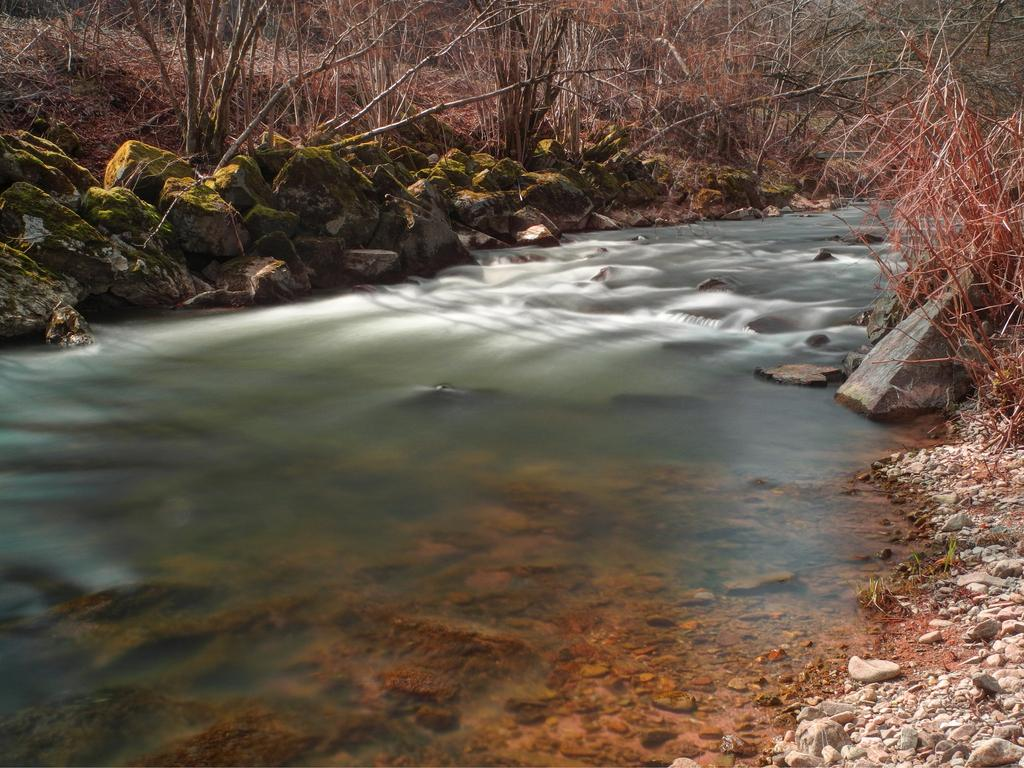What type of natural feature can be seen in the image? There is a water body in the image. What objects are present near the water body? Stones are present in the image. What type of vegetation is visible near the water body? Dry trees are visible in the image. What country is depicted in the image? The image does not depict a country; it features a water body, stones, and dry trees. How does the vessel navigate through the waves in the image? There is no vessel or waves present in the image. 